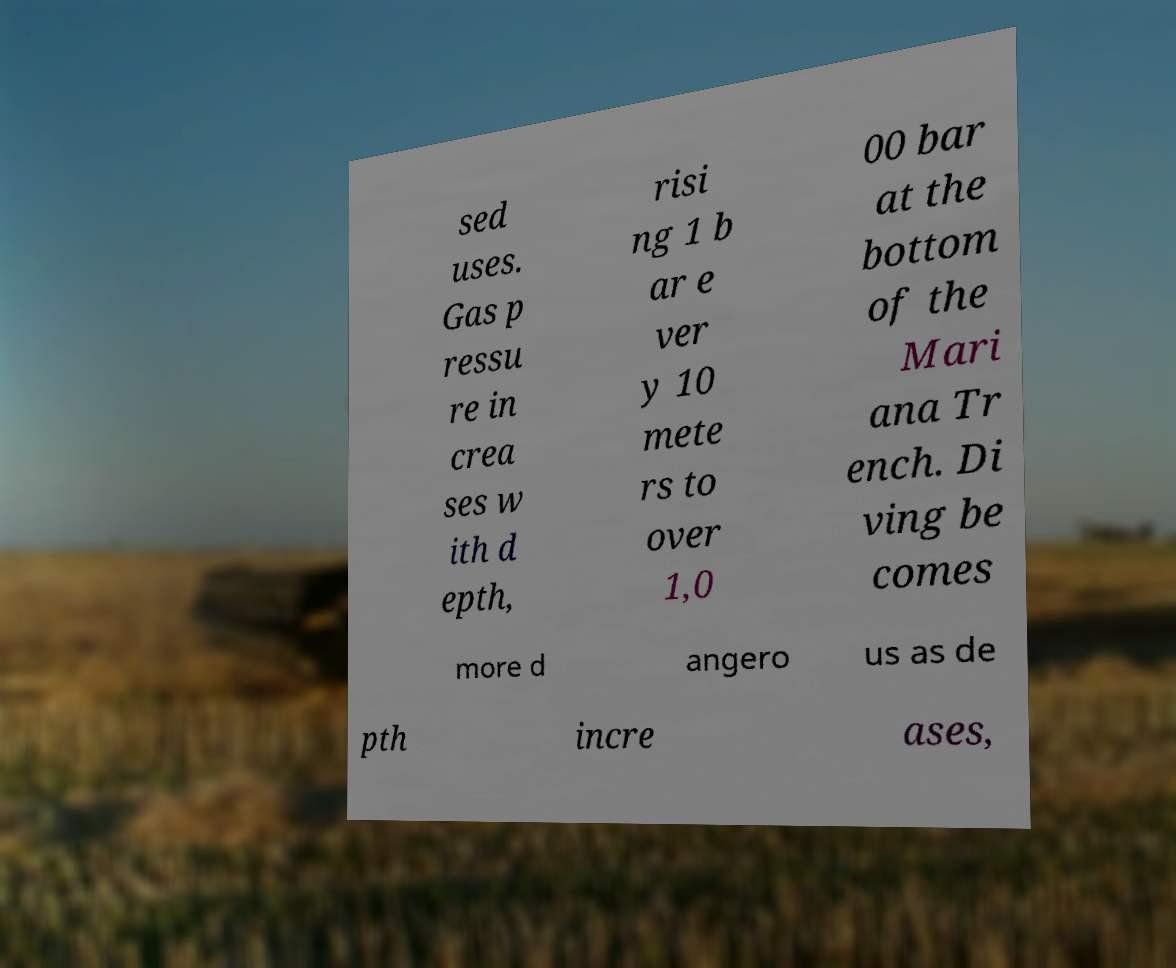There's text embedded in this image that I need extracted. Can you transcribe it verbatim? sed uses. Gas p ressu re in crea ses w ith d epth, risi ng 1 b ar e ver y 10 mete rs to over 1,0 00 bar at the bottom of the Mari ana Tr ench. Di ving be comes more d angero us as de pth incre ases, 